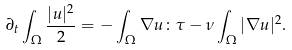<formula> <loc_0><loc_0><loc_500><loc_500>\partial _ { t } \int _ { \Omega } \frac { | u | ^ { 2 } } { 2 } = - \int _ { \Omega } \nabla u \colon \tau - \nu \int _ { \Omega } | \nabla u | ^ { 2 } .</formula> 